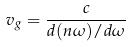Convert formula to latex. <formula><loc_0><loc_0><loc_500><loc_500>v _ { g } = \frac { c } { d ( n \omega ) / d \omega }</formula> 